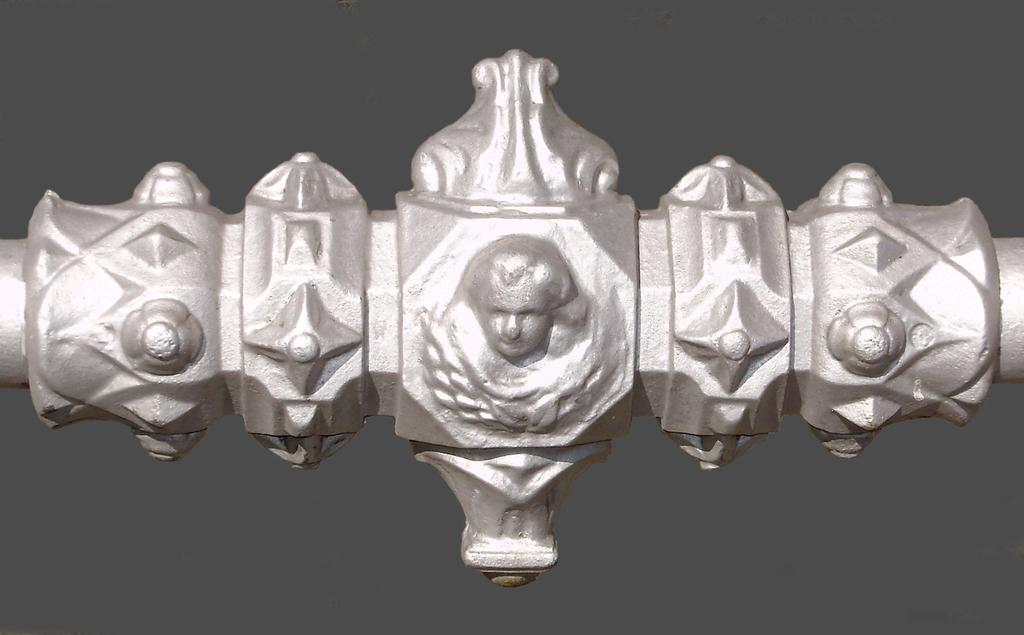What is the main subject of the image? There is an object in the image. Can you describe the object in more detail? There is a person's structure in the center of the object. Where is the meeting taking place in the image? There is no meeting present in the image; it only features an object with a person's structure in the center. 